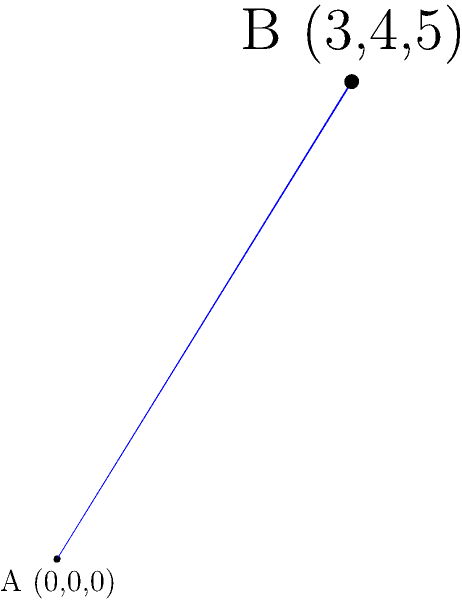In a distributed system, two servers are located at points A(0,0,0) and B(3,4,5) in a 3D coordinate system representing their geographical positions. Calculate the Euclidean distance between these two servers to determine the potential latency between them. Round your answer to two decimal places. To calculate the Euclidean distance between two points in 3D space, we can use the distance formula:

$$ d = \sqrt{(x_2-x_1)^2 + (y_2-y_1)^2 + (z_2-z_1)^2} $$

Where $(x_1,y_1,z_1)$ are the coordinates of point A and $(x_2,y_2,z_2)$ are the coordinates of point B.

Step 1: Identify the coordinates
- Point A: (0,0,0)
- Point B: (3,4,5)

Step 2: Apply the formula
$$ d = \sqrt{(3-0)^2 + (4-0)^2 + (5-0)^2} $$

Step 3: Simplify
$$ d = \sqrt{3^2 + 4^2 + 5^2} $$
$$ d = \sqrt{9 + 16 + 25} $$
$$ d = \sqrt{50} $$

Step 4: Calculate the square root and round to two decimal places
$$ d \approx 7.07 $$

Therefore, the Euclidean distance between the two servers is approximately 7.07 units.
Answer: 7.07 units 